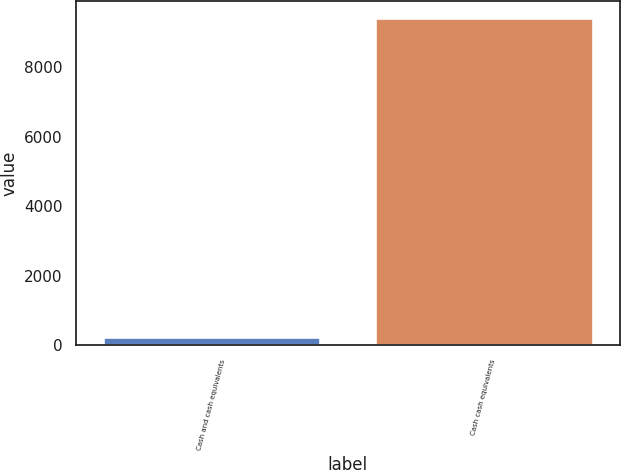Convert chart to OTSL. <chart><loc_0><loc_0><loc_500><loc_500><bar_chart><fcel>Cash and cash equivalents<fcel>Cash cash equivalents<nl><fcel>246<fcel>9415.4<nl></chart> 